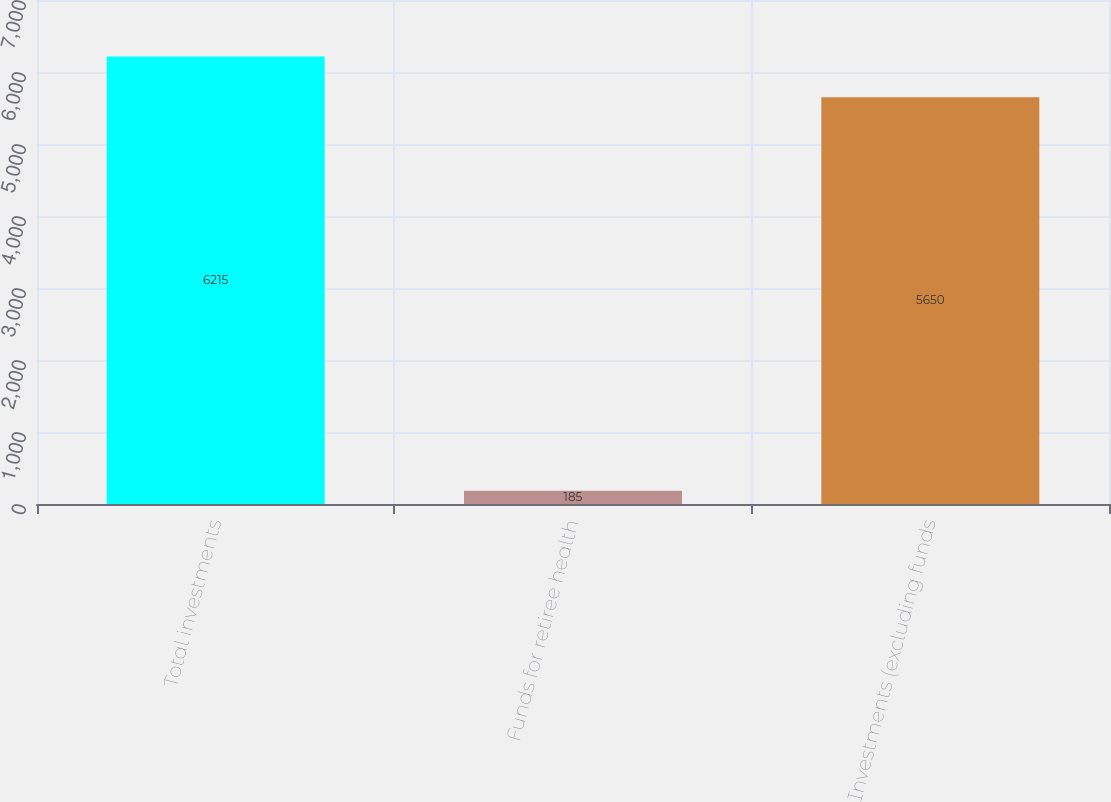Convert chart to OTSL. <chart><loc_0><loc_0><loc_500><loc_500><bar_chart><fcel>Total investments<fcel>Funds for retiree health<fcel>Investments (excluding funds<nl><fcel>6215<fcel>185<fcel>5650<nl></chart> 